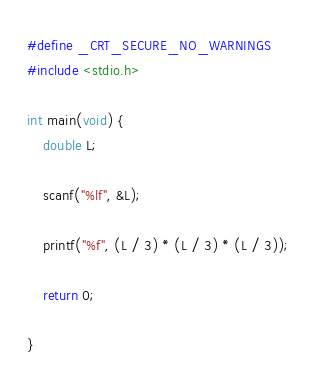<code> <loc_0><loc_0><loc_500><loc_500><_C_>#define _CRT_SECURE_NO_WARNINGS
#include <stdio.h>

int main(void) {
	double L;

	scanf("%lf", &L);

	printf("%f", (L / 3) * (L / 3) * (L / 3));

	return 0;
	
}</code> 